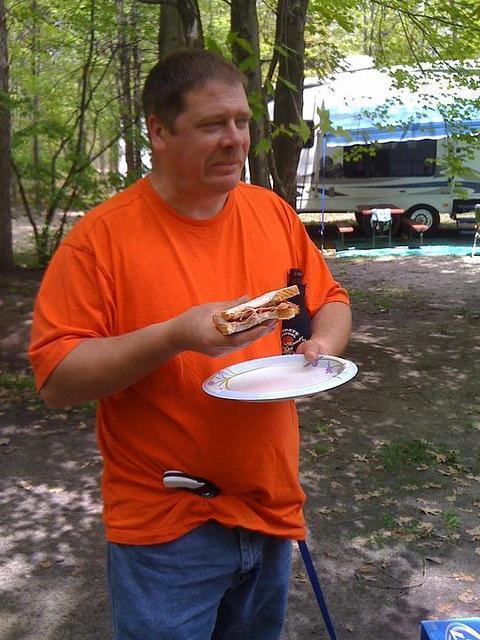How would this man defend himself if attacked?
Make your selection and explain in format: 'Answer: answer
Rationale: rationale.'
Options: Gun, knife, karate, he wouldn't. Answer: gun.
Rationale: Guns are frequently used as self defense items and there is a gun handle visible protruding from his shirt and pants. if attacked this, being in arms reach, would likely be the most effective and most practical item to use for defense. 